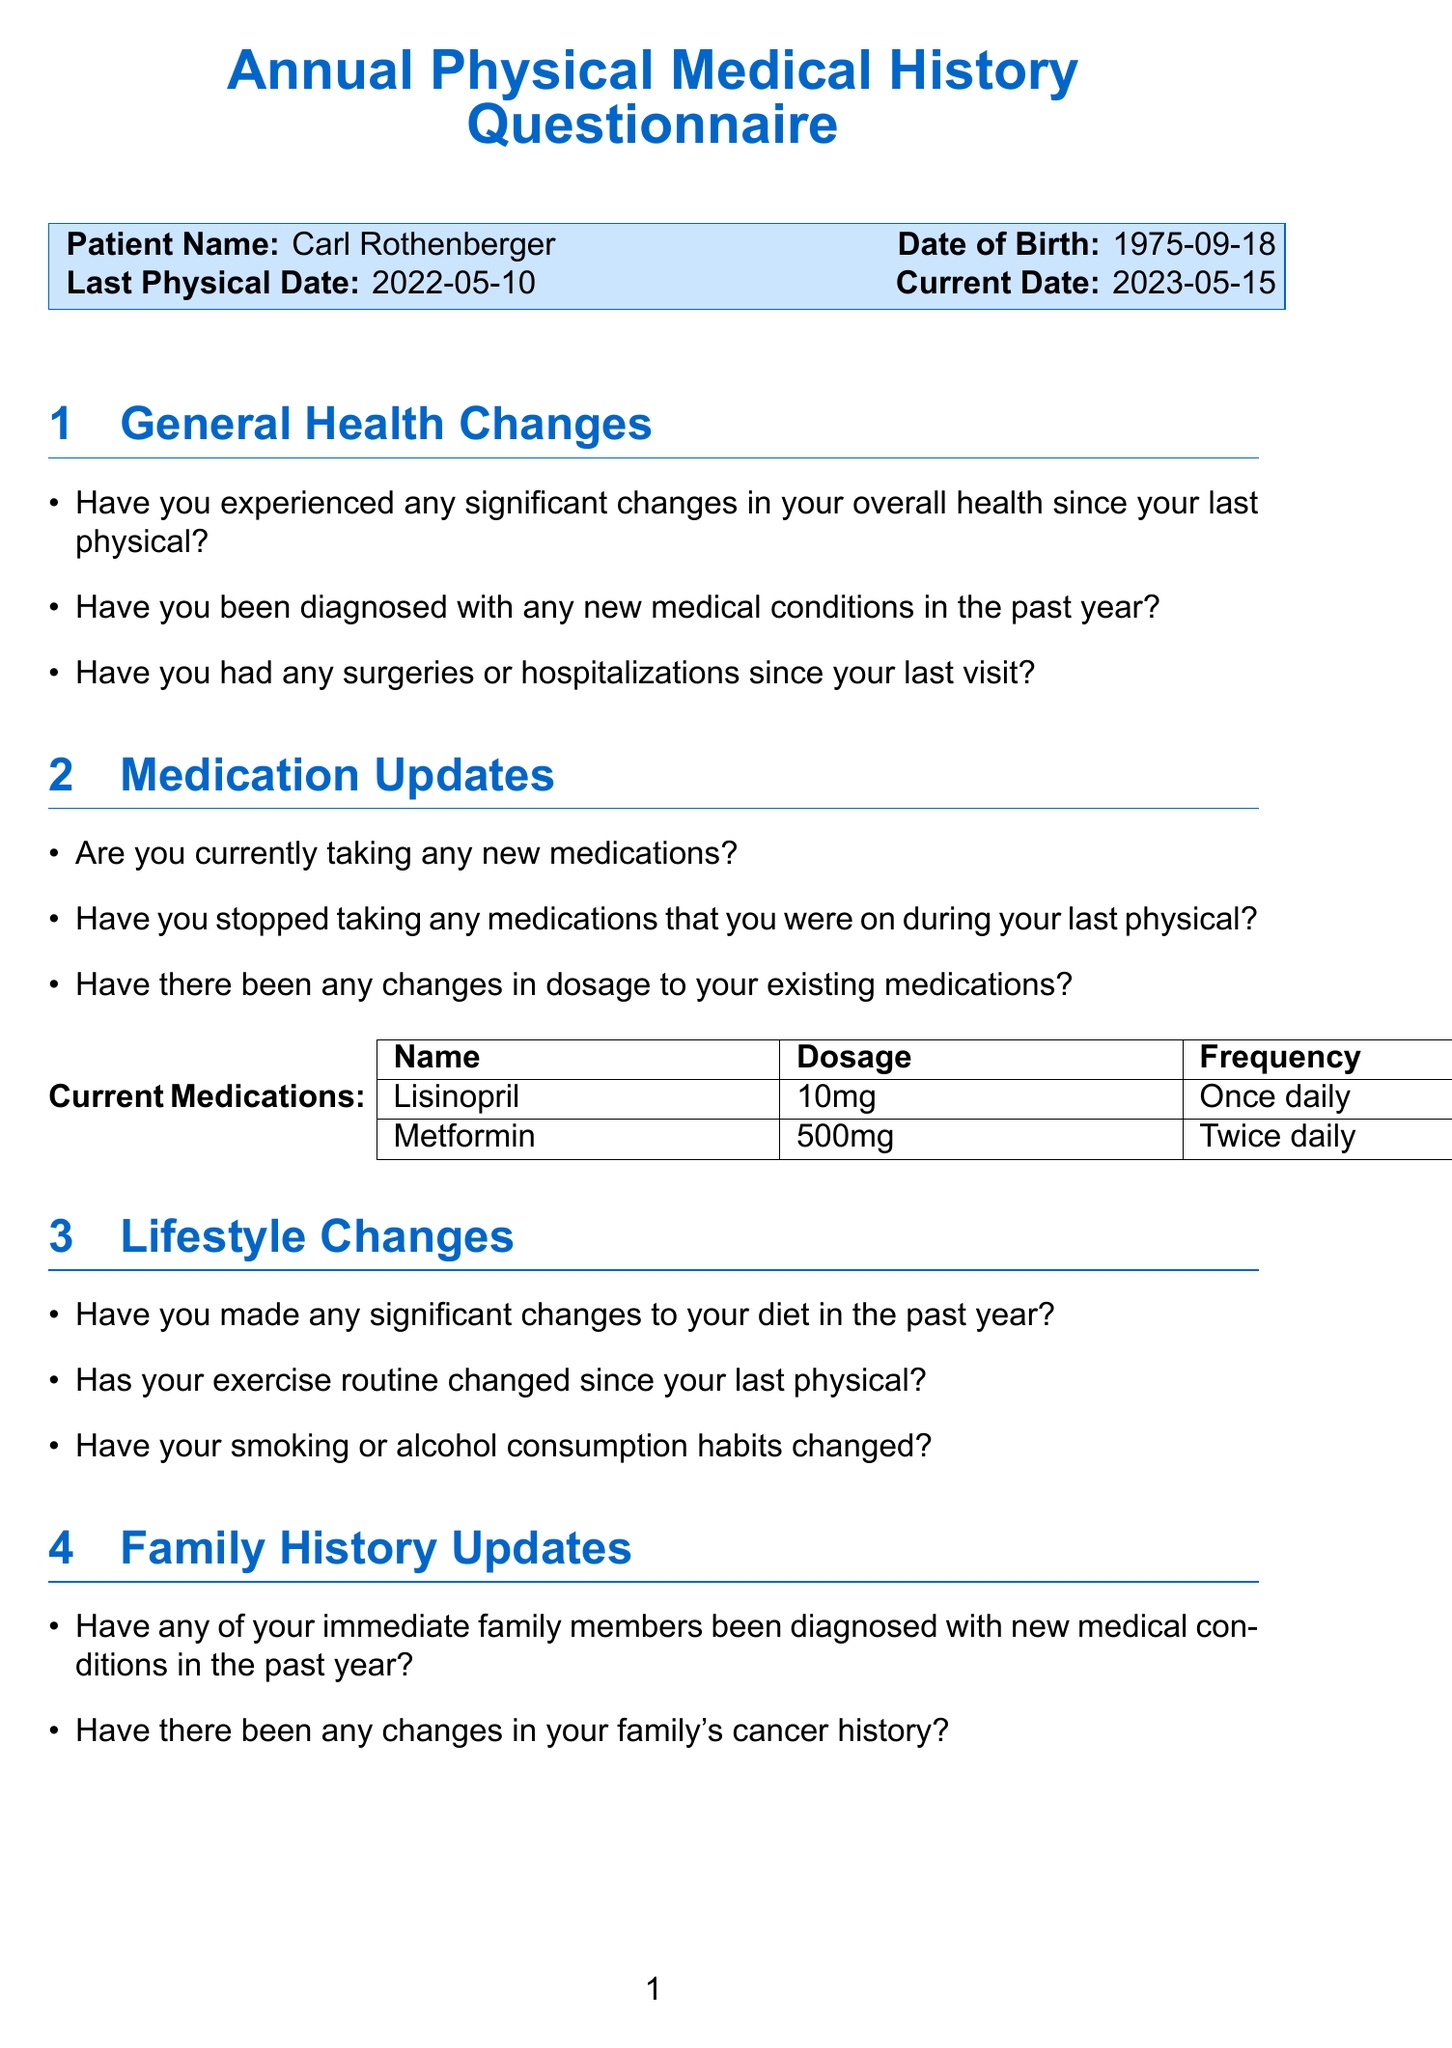What is Carl Rothenberger's date of birth? The date of birth is stated in the patient information section of the document.
Answer: 1975-09-18 When was Carl's last physical examination? The last physical date is specified in the document under patient information.
Answer: 2022-05-10 What medications is Carl currently taking? The current medications section lists the medications Carl is taking.
Answer: Lisinopril, Metformin What is the dosage of Lisinopril? The dosage information for Lisinopril is provided in the medications section of the document.
Answer: 10mg Has Carl experienced any significant stress in the past year? This question is found in the mental health section of the questionnaire, specifically asking about stress.
Answer: (Answer needed from Carl) How often does Carl take Metformin? The frequency of Metformin is detailed in the current medications section.
Answer: Twice daily Did Carl travel outside the country in the past year? This question is associated with the travel history section of the questionnaire.
Answer: (Answer needed from Carl) Who is Carl's primary care physician? The name of the primary care physician is mentioned in the physician section.
Answer: Dr. Emily Johnson 